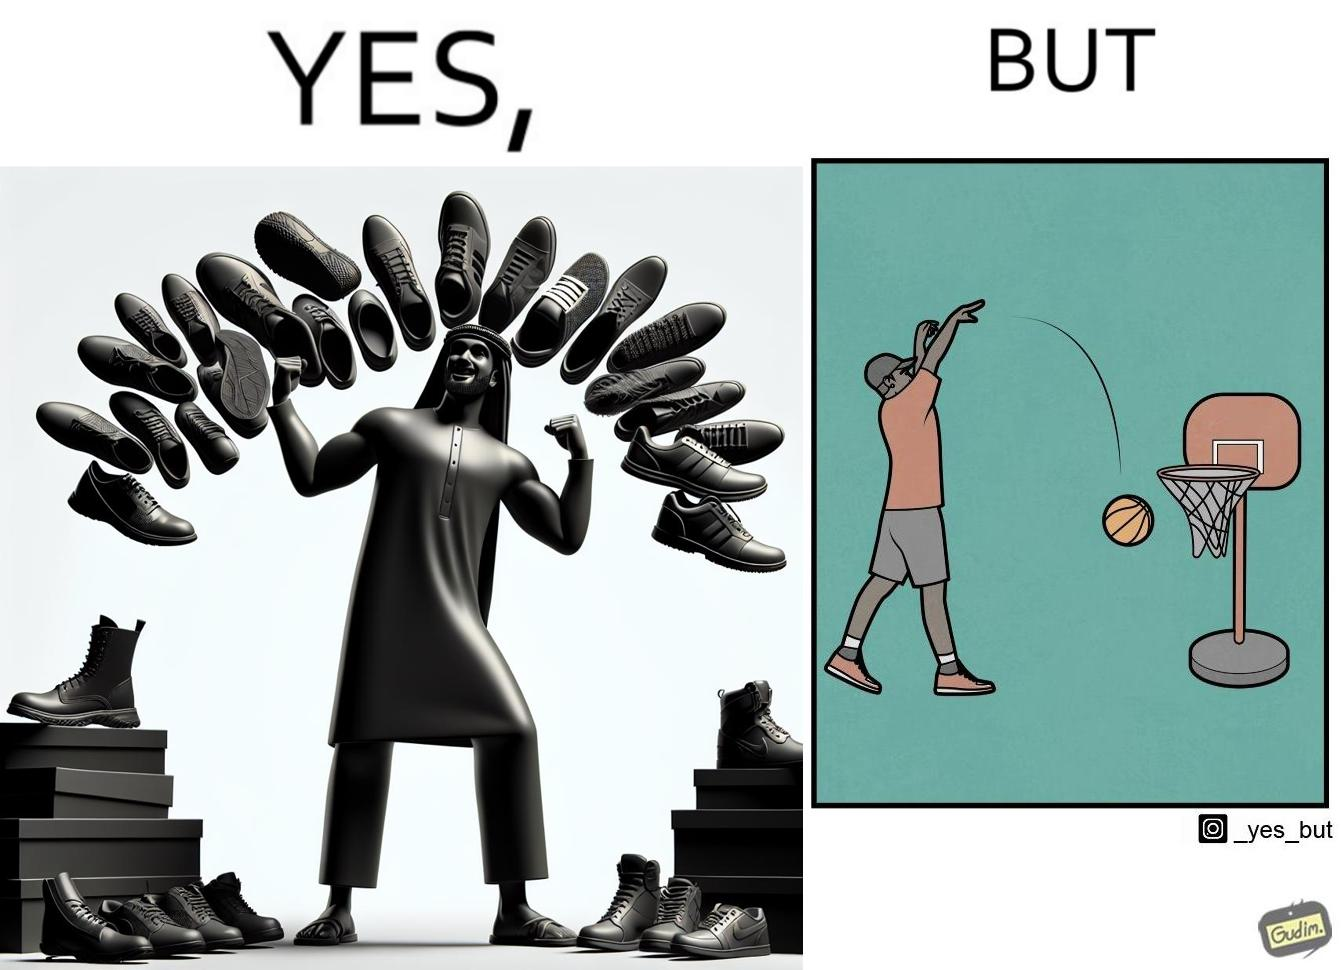Explain the humor or irony in this image. The image is ironic, because even when the person has a large collection of shoes even then he is not able to basket a ball in a small height net 